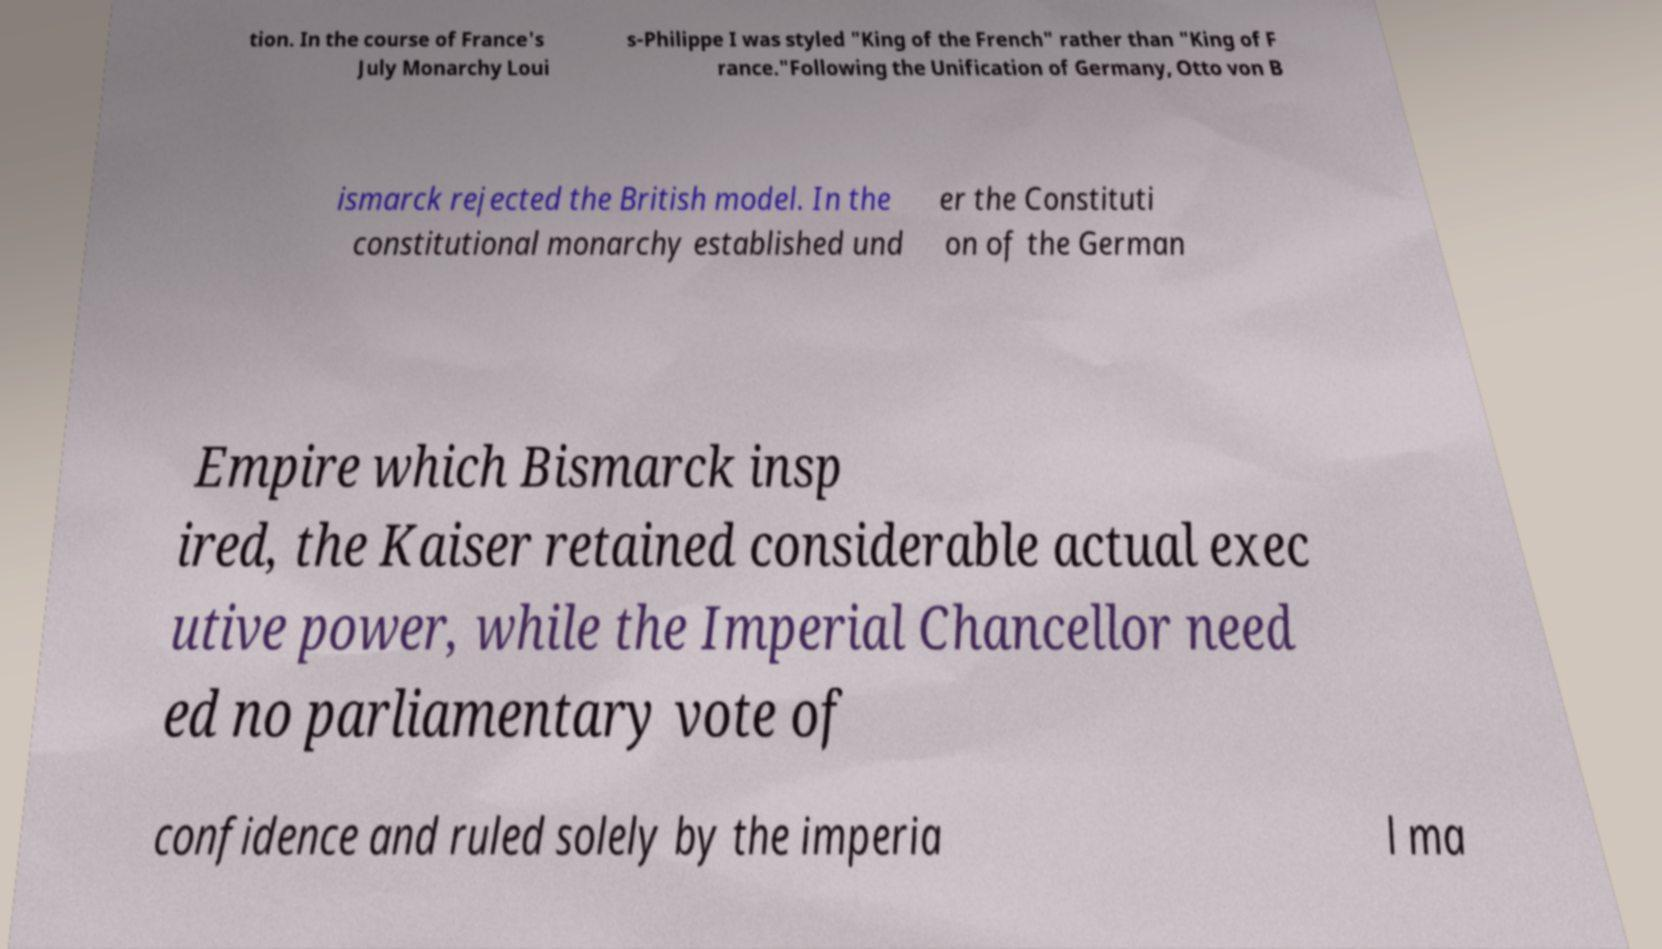For documentation purposes, I need the text within this image transcribed. Could you provide that? tion. In the course of France's July Monarchy Loui s-Philippe I was styled "King of the French" rather than "King of F rance."Following the Unification of Germany, Otto von B ismarck rejected the British model. In the constitutional monarchy established und er the Constituti on of the German Empire which Bismarck insp ired, the Kaiser retained considerable actual exec utive power, while the Imperial Chancellor need ed no parliamentary vote of confidence and ruled solely by the imperia l ma 